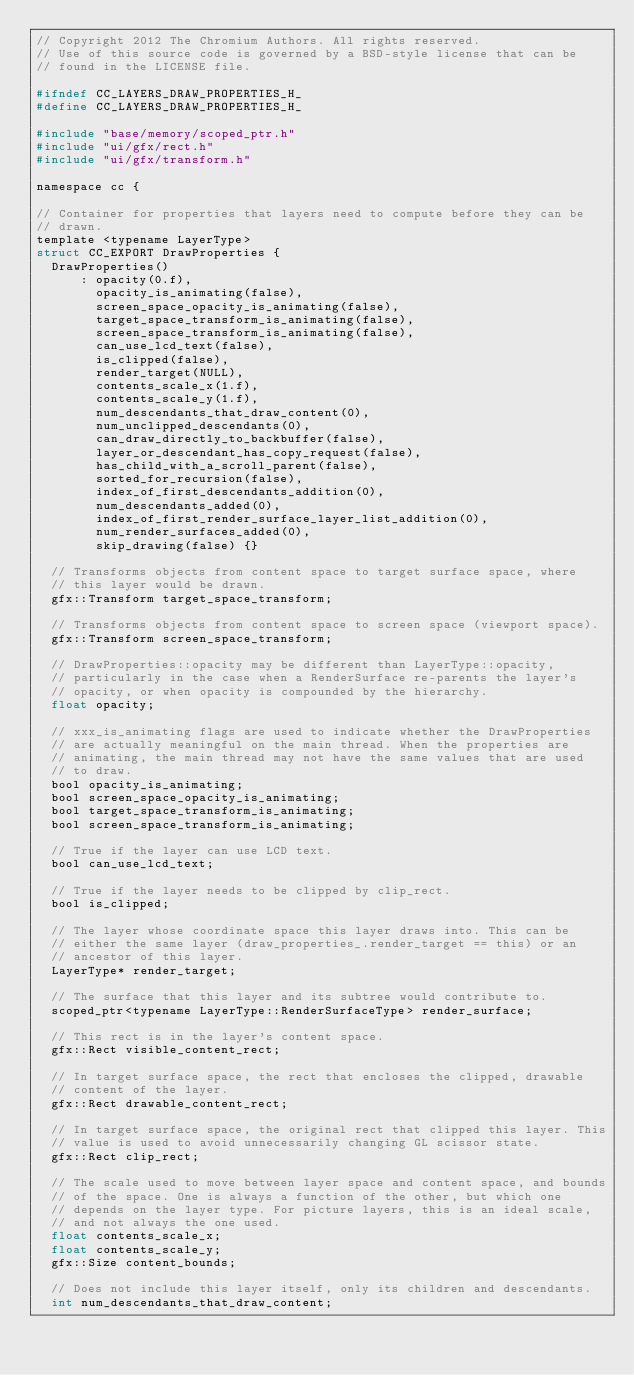<code> <loc_0><loc_0><loc_500><loc_500><_C_>// Copyright 2012 The Chromium Authors. All rights reserved.
// Use of this source code is governed by a BSD-style license that can be
// found in the LICENSE file.

#ifndef CC_LAYERS_DRAW_PROPERTIES_H_
#define CC_LAYERS_DRAW_PROPERTIES_H_

#include "base/memory/scoped_ptr.h"
#include "ui/gfx/rect.h"
#include "ui/gfx/transform.h"

namespace cc {

// Container for properties that layers need to compute before they can be
// drawn.
template <typename LayerType>
struct CC_EXPORT DrawProperties {
  DrawProperties()
      : opacity(0.f),
        opacity_is_animating(false),
        screen_space_opacity_is_animating(false),
        target_space_transform_is_animating(false),
        screen_space_transform_is_animating(false),
        can_use_lcd_text(false),
        is_clipped(false),
        render_target(NULL),
        contents_scale_x(1.f),
        contents_scale_y(1.f),
        num_descendants_that_draw_content(0),
        num_unclipped_descendants(0),
        can_draw_directly_to_backbuffer(false),
        layer_or_descendant_has_copy_request(false),
        has_child_with_a_scroll_parent(false),
        sorted_for_recursion(false),
        index_of_first_descendants_addition(0),
        num_descendants_added(0),
        index_of_first_render_surface_layer_list_addition(0),
        num_render_surfaces_added(0),
        skip_drawing(false) {}

  // Transforms objects from content space to target surface space, where
  // this layer would be drawn.
  gfx::Transform target_space_transform;

  // Transforms objects from content space to screen space (viewport space).
  gfx::Transform screen_space_transform;

  // DrawProperties::opacity may be different than LayerType::opacity,
  // particularly in the case when a RenderSurface re-parents the layer's
  // opacity, or when opacity is compounded by the hierarchy.
  float opacity;

  // xxx_is_animating flags are used to indicate whether the DrawProperties
  // are actually meaningful on the main thread. When the properties are
  // animating, the main thread may not have the same values that are used
  // to draw.
  bool opacity_is_animating;
  bool screen_space_opacity_is_animating;
  bool target_space_transform_is_animating;
  bool screen_space_transform_is_animating;

  // True if the layer can use LCD text.
  bool can_use_lcd_text;

  // True if the layer needs to be clipped by clip_rect.
  bool is_clipped;

  // The layer whose coordinate space this layer draws into. This can be
  // either the same layer (draw_properties_.render_target == this) or an
  // ancestor of this layer.
  LayerType* render_target;

  // The surface that this layer and its subtree would contribute to.
  scoped_ptr<typename LayerType::RenderSurfaceType> render_surface;

  // This rect is in the layer's content space.
  gfx::Rect visible_content_rect;

  // In target surface space, the rect that encloses the clipped, drawable
  // content of the layer.
  gfx::Rect drawable_content_rect;

  // In target surface space, the original rect that clipped this layer. This
  // value is used to avoid unnecessarily changing GL scissor state.
  gfx::Rect clip_rect;

  // The scale used to move between layer space and content space, and bounds
  // of the space. One is always a function of the other, but which one
  // depends on the layer type. For picture layers, this is an ideal scale,
  // and not always the one used.
  float contents_scale_x;
  float contents_scale_y;
  gfx::Size content_bounds;

  // Does not include this layer itself, only its children and descendants.
  int num_descendants_that_draw_content;
</code> 